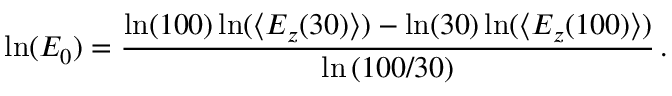Convert formula to latex. <formula><loc_0><loc_0><loc_500><loc_500>\ln ( E _ { 0 } ) = \frac { \ln ( 1 0 0 ) \ln ( \langle E _ { z } ( 3 0 ) \rangle ) - \ln ( 3 0 ) \ln ( \langle E _ { z } ( 1 0 0 ) \rangle ) } { \ln { ( 1 0 0 / 3 0 ) } } \, .</formula> 